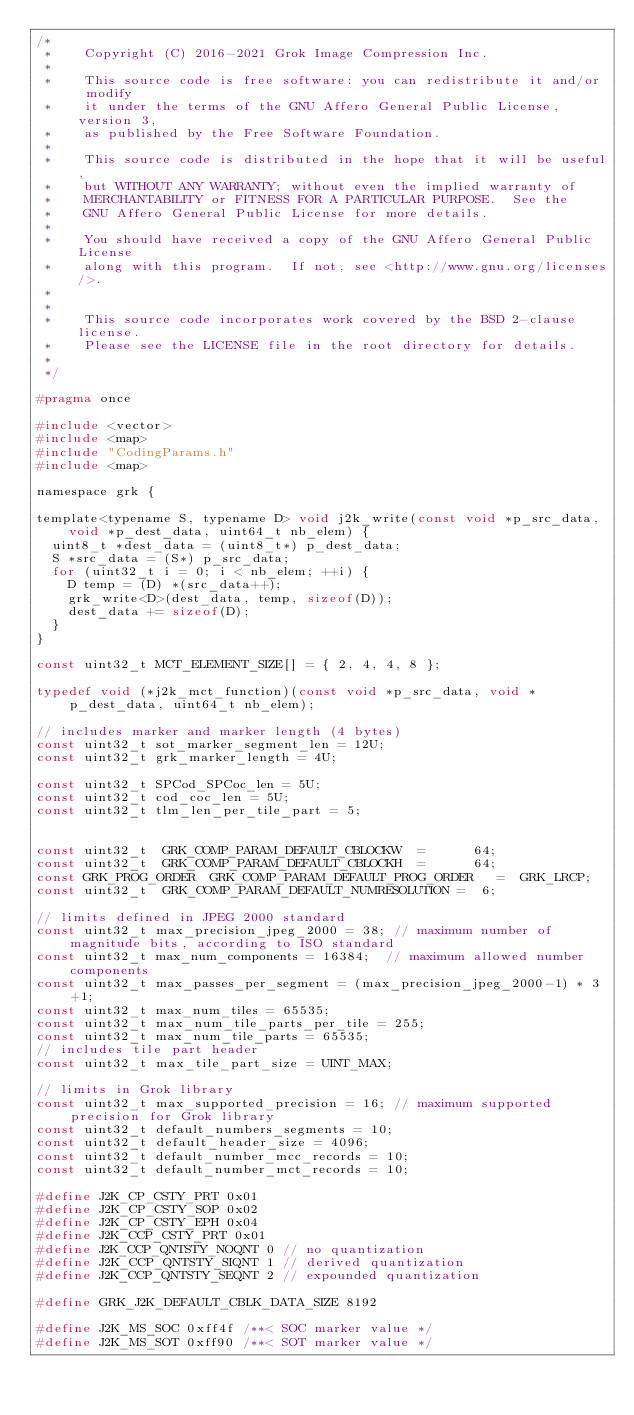Convert code to text. <code><loc_0><loc_0><loc_500><loc_500><_C_>/*
 *    Copyright (C) 2016-2021 Grok Image Compression Inc.
 *
 *    This source code is free software: you can redistribute it and/or  modify
 *    it under the terms of the GNU Affero General Public License, version 3,
 *    as published by the Free Software Foundation.
 *
 *    This source code is distributed in the hope that it will be useful,
 *    but WITHOUT ANY WARRANTY; without even the implied warranty of
 *    MERCHANTABILITY or FITNESS FOR A PARTICULAR PURPOSE.  See the
 *    GNU Affero General Public License for more details.
 *
 *    You should have received a copy of the GNU Affero General Public License
 *    along with this program.  If not, see <http://www.gnu.org/licenses/>.
 *
 *
 *    This source code incorporates work covered by the BSD 2-clause license.
 *    Please see the LICENSE file in the root directory for details.
 *
 */

#pragma once

#include <vector>
#include <map>
#include "CodingParams.h"
#include <map>

namespace grk {

template<typename S, typename D> void j2k_write(const void *p_src_data,
		void *p_dest_data, uint64_t nb_elem) {
	uint8_t *dest_data = (uint8_t*) p_dest_data;
	S *src_data = (S*) p_src_data;
	for (uint32_t i = 0; i < nb_elem; ++i) {
		D temp = (D) *(src_data++);
		grk_write<D>(dest_data, temp, sizeof(D));
		dest_data += sizeof(D);
	}
}

const uint32_t MCT_ELEMENT_SIZE[] = { 2, 4, 4, 8 };

typedef void (*j2k_mct_function)(const void *p_src_data, void *p_dest_data,	uint64_t nb_elem);

// includes marker and marker length (4 bytes)
const uint32_t sot_marker_segment_len = 12U;
const uint32_t grk_marker_length = 4U;

const uint32_t SPCod_SPCoc_len = 5U;
const uint32_t cod_coc_len = 5U;
const uint32_t tlm_len_per_tile_part = 5;


const uint32_t  GRK_COMP_PARAM_DEFAULT_CBLOCKW  =      64;
const uint32_t  GRK_COMP_PARAM_DEFAULT_CBLOCKH  =      64;
const GRK_PROG_ORDER  GRK_COMP_PARAM_DEFAULT_PROG_ORDER   =  GRK_LRCP;
const uint32_t  GRK_COMP_PARAM_DEFAULT_NUMRESOLUTION =  6;

// limits defined in JPEG 2000 standard
const uint32_t max_precision_jpeg_2000 = 38; // maximum number of magnitude bits, according to ISO standard
const uint32_t max_num_components = 16384;	// maximum allowed number components
const uint32_t max_passes_per_segment = (max_precision_jpeg_2000-1) * 3 +1;
const uint32_t max_num_tiles = 65535;
const uint32_t max_num_tile_parts_per_tile = 255;
const uint32_t max_num_tile_parts = 65535;
// includes tile part header
const uint32_t max_tile_part_size = UINT_MAX;

// limits in Grok library
const uint32_t max_supported_precision = 16; // maximum supported precision for Grok library
const uint32_t default_numbers_segments = 10;
const uint32_t default_header_size = 4096;
const uint32_t default_number_mcc_records = 10;
const uint32_t default_number_mct_records = 10;

#define J2K_CP_CSTY_PRT 0x01
#define J2K_CP_CSTY_SOP 0x02
#define J2K_CP_CSTY_EPH 0x04
#define J2K_CCP_CSTY_PRT 0x01
#define J2K_CCP_QNTSTY_NOQNT 0 // no quantization
#define J2K_CCP_QNTSTY_SIQNT 1 // derived quantization
#define J2K_CCP_QNTSTY_SEQNT 2 // expounded quantization

#define GRK_J2K_DEFAULT_CBLK_DATA_SIZE 8192

#define J2K_MS_SOC 0xff4f	/**< SOC marker value */
#define J2K_MS_SOT 0xff90	/**< SOT marker value */</code> 